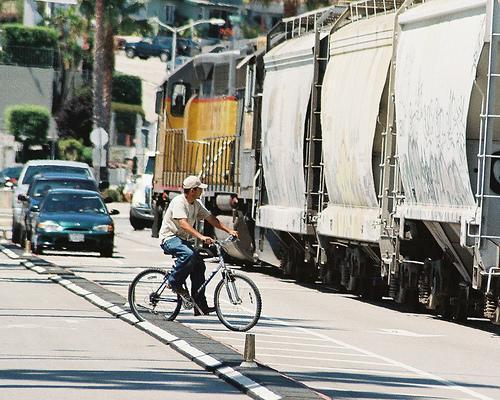How many bikes are in the photo?
Give a very brief answer. 1. How many hands does the man have on the bike?
Give a very brief answer. 2. How many tires are on the bike?
Give a very brief answer. 2. How many cars are there in the photo?
Give a very brief answer. 3. How many buses are solid blue?
Give a very brief answer. 0. 